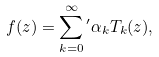Convert formula to latex. <formula><loc_0><loc_0><loc_500><loc_500>f ( z ) = \sum _ { k = 0 } ^ { \infty } { ^ { \prime } } \alpha _ { k } T _ { k } ( z ) ,</formula> 